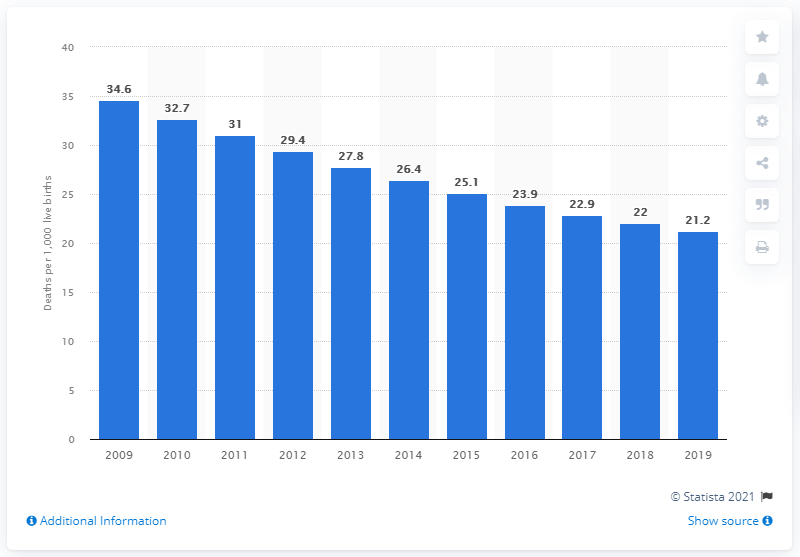Identify some key points in this picture. In 2019, the infant mortality rate in Bolivia was 21.2 deaths per 1,000 live births. 